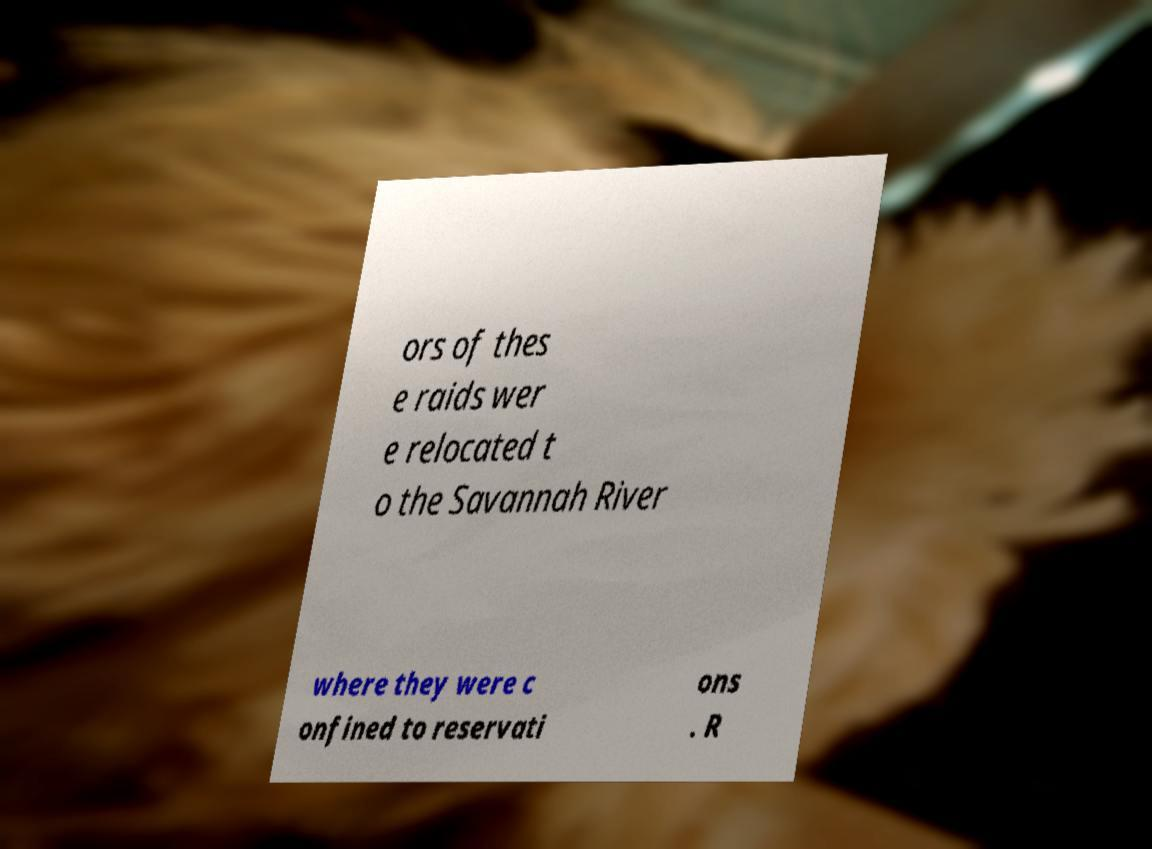Please read and relay the text visible in this image. What does it say? ors of thes e raids wer e relocated t o the Savannah River where they were c onfined to reservati ons . R 